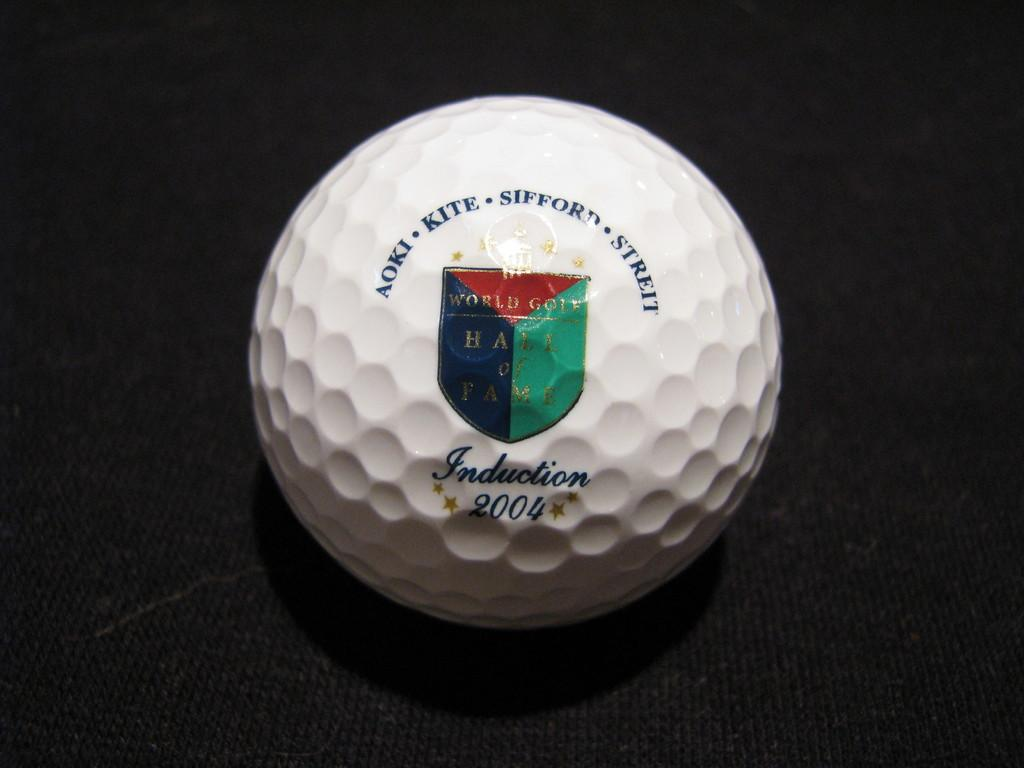What object is present in the image? There is a ball in the image. What can be found on the surface of the ball? The ball has text and numbers written on it. What scent can be detected from the ball in the image? There is no mention of a scent associated with the ball in the image, so it cannot be determined from the image. 